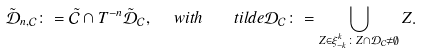<formula> <loc_0><loc_0><loc_500><loc_500>\tilde { \mathcal { D } } _ { n , \mathcal { C } } \colon = \tilde { \mathcal { C } } \cap T ^ { - n } \tilde { \mathcal { D } } _ { \mathcal { C } } , \ \ w i t h \ \ \ t i l d e { \mathcal { D } } _ { \mathcal { C } } \colon = \bigcup _ { Z \in \xi _ { - k } ^ { k } \colon Z \cap { \mathcal { D } } _ { \mathcal { C } } \ne \emptyset } Z .</formula> 